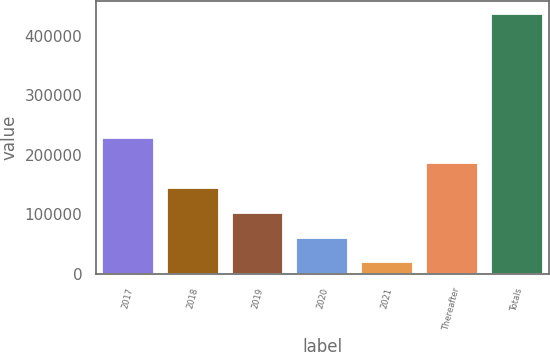Convert chart to OTSL. <chart><loc_0><loc_0><loc_500><loc_500><bar_chart><fcel>2017<fcel>2018<fcel>2019<fcel>2020<fcel>2021<fcel>Thereafter<fcel>Totals<nl><fcel>227608<fcel>144182<fcel>102470<fcel>60757.5<fcel>19045<fcel>185895<fcel>436170<nl></chart> 